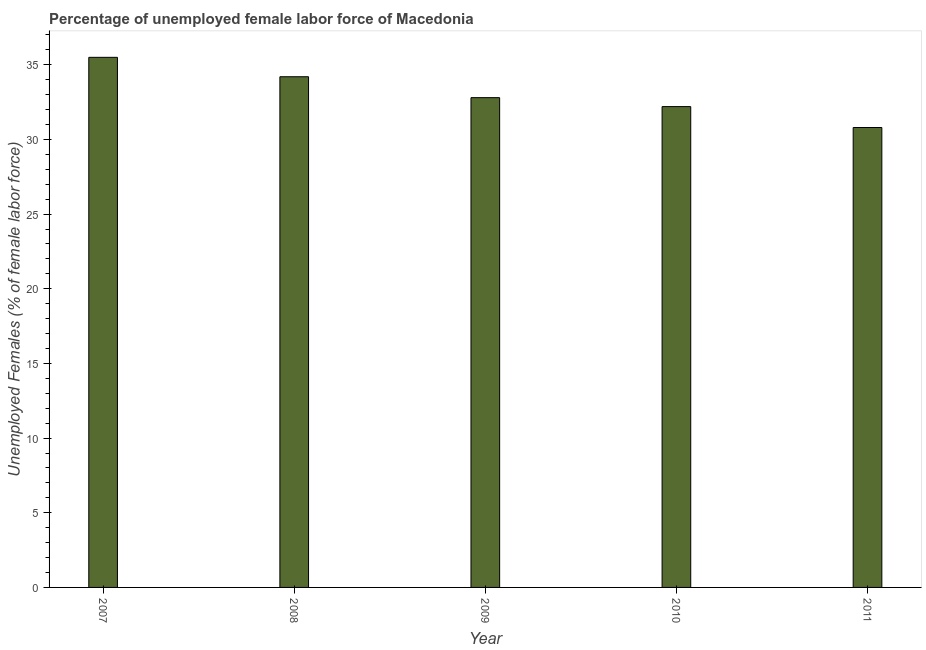Does the graph contain any zero values?
Provide a short and direct response. No. What is the title of the graph?
Offer a very short reply. Percentage of unemployed female labor force of Macedonia. What is the label or title of the X-axis?
Make the answer very short. Year. What is the label or title of the Y-axis?
Give a very brief answer. Unemployed Females (% of female labor force). What is the total unemployed female labour force in 2010?
Provide a short and direct response. 32.2. Across all years, what is the maximum total unemployed female labour force?
Give a very brief answer. 35.5. Across all years, what is the minimum total unemployed female labour force?
Give a very brief answer. 30.8. In which year was the total unemployed female labour force maximum?
Give a very brief answer. 2007. What is the sum of the total unemployed female labour force?
Ensure brevity in your answer.  165.5. What is the difference between the total unemployed female labour force in 2009 and 2010?
Ensure brevity in your answer.  0.6. What is the average total unemployed female labour force per year?
Offer a terse response. 33.1. What is the median total unemployed female labour force?
Make the answer very short. 32.8. Do a majority of the years between 2008 and 2007 (inclusive) have total unemployed female labour force greater than 27 %?
Keep it short and to the point. No. What is the ratio of the total unemployed female labour force in 2008 to that in 2011?
Keep it short and to the point. 1.11. What is the difference between the highest and the second highest total unemployed female labour force?
Provide a succinct answer. 1.3. What is the difference between the highest and the lowest total unemployed female labour force?
Provide a succinct answer. 4.7. In how many years, is the total unemployed female labour force greater than the average total unemployed female labour force taken over all years?
Provide a short and direct response. 2. How many years are there in the graph?
Offer a very short reply. 5. What is the difference between two consecutive major ticks on the Y-axis?
Provide a short and direct response. 5. What is the Unemployed Females (% of female labor force) of 2007?
Provide a short and direct response. 35.5. What is the Unemployed Females (% of female labor force) in 2008?
Your response must be concise. 34.2. What is the Unemployed Females (% of female labor force) of 2009?
Keep it short and to the point. 32.8. What is the Unemployed Females (% of female labor force) of 2010?
Your response must be concise. 32.2. What is the Unemployed Females (% of female labor force) in 2011?
Ensure brevity in your answer.  30.8. What is the difference between the Unemployed Females (% of female labor force) in 2007 and 2008?
Your answer should be compact. 1.3. What is the difference between the Unemployed Females (% of female labor force) in 2007 and 2009?
Ensure brevity in your answer.  2.7. What is the difference between the Unemployed Females (% of female labor force) in 2007 and 2011?
Provide a short and direct response. 4.7. What is the difference between the Unemployed Females (% of female labor force) in 2009 and 2010?
Provide a succinct answer. 0.6. What is the ratio of the Unemployed Females (% of female labor force) in 2007 to that in 2008?
Offer a terse response. 1.04. What is the ratio of the Unemployed Females (% of female labor force) in 2007 to that in 2009?
Your answer should be compact. 1.08. What is the ratio of the Unemployed Females (% of female labor force) in 2007 to that in 2010?
Your answer should be very brief. 1.1. What is the ratio of the Unemployed Females (% of female labor force) in 2007 to that in 2011?
Provide a short and direct response. 1.15. What is the ratio of the Unemployed Females (% of female labor force) in 2008 to that in 2009?
Provide a short and direct response. 1.04. What is the ratio of the Unemployed Females (% of female labor force) in 2008 to that in 2010?
Offer a terse response. 1.06. What is the ratio of the Unemployed Females (% of female labor force) in 2008 to that in 2011?
Keep it short and to the point. 1.11. What is the ratio of the Unemployed Females (% of female labor force) in 2009 to that in 2010?
Your answer should be very brief. 1.02. What is the ratio of the Unemployed Females (% of female labor force) in 2009 to that in 2011?
Your answer should be compact. 1.06. What is the ratio of the Unemployed Females (% of female labor force) in 2010 to that in 2011?
Your answer should be compact. 1.04. 